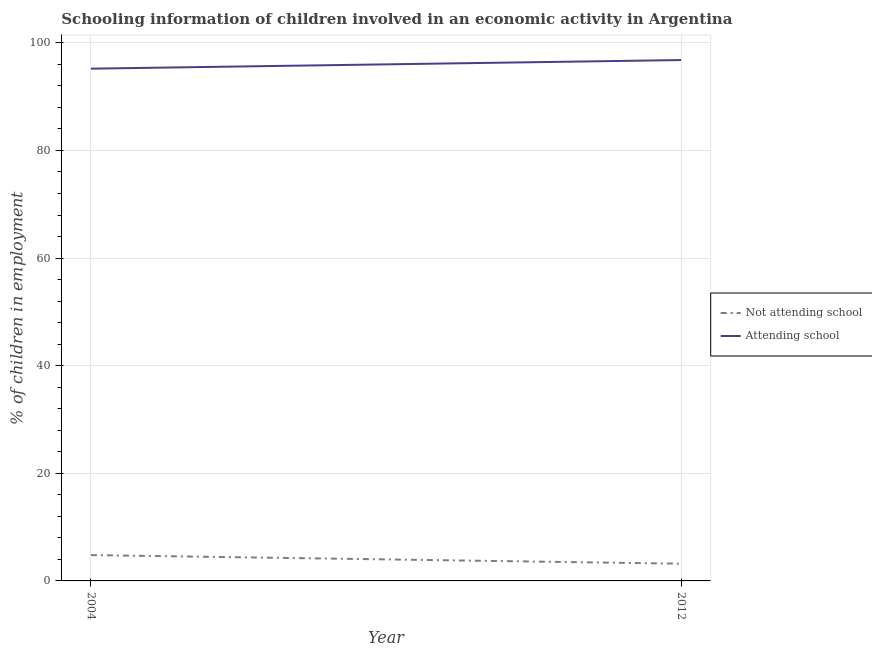Does the line corresponding to percentage of employed children who are attending school intersect with the line corresponding to percentage of employed children who are not attending school?
Give a very brief answer. No. What is the percentage of employed children who are attending school in 2012?
Your answer should be very brief. 96.8. Across all years, what is the maximum percentage of employed children who are attending school?
Your answer should be very brief. 96.8. Across all years, what is the minimum percentage of employed children who are attending school?
Provide a short and direct response. 95.2. In which year was the percentage of employed children who are not attending school maximum?
Your answer should be compact. 2004. What is the difference between the percentage of employed children who are not attending school in 2004 and that in 2012?
Ensure brevity in your answer.  1.6. What is the difference between the percentage of employed children who are not attending school in 2012 and the percentage of employed children who are attending school in 2004?
Offer a terse response. -92. What is the average percentage of employed children who are attending school per year?
Keep it short and to the point. 96. In the year 2004, what is the difference between the percentage of employed children who are attending school and percentage of employed children who are not attending school?
Provide a short and direct response. 90.4. In how many years, is the percentage of employed children who are attending school greater than 4 %?
Your answer should be very brief. 2. What is the ratio of the percentage of employed children who are not attending school in 2004 to that in 2012?
Keep it short and to the point. 1.5. Is the percentage of employed children who are attending school strictly greater than the percentage of employed children who are not attending school over the years?
Your answer should be very brief. Yes. How many years are there in the graph?
Provide a short and direct response. 2. What is the difference between two consecutive major ticks on the Y-axis?
Your answer should be compact. 20. Are the values on the major ticks of Y-axis written in scientific E-notation?
Make the answer very short. No. Does the graph contain any zero values?
Your answer should be compact. No. Does the graph contain grids?
Keep it short and to the point. Yes. Where does the legend appear in the graph?
Ensure brevity in your answer.  Center right. How many legend labels are there?
Your answer should be very brief. 2. How are the legend labels stacked?
Your answer should be very brief. Vertical. What is the title of the graph?
Offer a very short reply. Schooling information of children involved in an economic activity in Argentina. What is the label or title of the Y-axis?
Provide a short and direct response. % of children in employment. What is the % of children in employment in Attending school in 2004?
Your response must be concise. 95.2. What is the % of children in employment of Attending school in 2012?
Ensure brevity in your answer.  96.8. Across all years, what is the maximum % of children in employment of Attending school?
Your answer should be very brief. 96.8. Across all years, what is the minimum % of children in employment of Attending school?
Your response must be concise. 95.2. What is the total % of children in employment of Not attending school in the graph?
Provide a short and direct response. 8. What is the total % of children in employment in Attending school in the graph?
Keep it short and to the point. 192. What is the difference between the % of children in employment in Not attending school in 2004 and that in 2012?
Provide a succinct answer. 1.6. What is the difference between the % of children in employment of Attending school in 2004 and that in 2012?
Ensure brevity in your answer.  -1.6. What is the difference between the % of children in employment in Not attending school in 2004 and the % of children in employment in Attending school in 2012?
Provide a short and direct response. -92. What is the average % of children in employment of Attending school per year?
Offer a terse response. 96. In the year 2004, what is the difference between the % of children in employment in Not attending school and % of children in employment in Attending school?
Your response must be concise. -90.4. In the year 2012, what is the difference between the % of children in employment of Not attending school and % of children in employment of Attending school?
Ensure brevity in your answer.  -93.6. What is the ratio of the % of children in employment of Attending school in 2004 to that in 2012?
Give a very brief answer. 0.98. What is the difference between the highest and the second highest % of children in employment in Not attending school?
Provide a succinct answer. 1.6. What is the difference between the highest and the second highest % of children in employment of Attending school?
Give a very brief answer. 1.6. What is the difference between the highest and the lowest % of children in employment in Not attending school?
Make the answer very short. 1.6. 